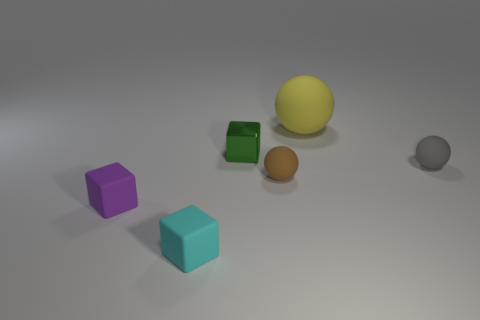Is there anything else that has the same material as the green thing?
Ensure brevity in your answer.  No. There is a rubber thing that is both in front of the tiny metal cube and right of the small brown rubber object; what is its size?
Provide a short and direct response. Small. There is a tiny thing that is behind the small gray thing; what shape is it?
Make the answer very short. Cube. Are the gray object and the small thing that is in front of the purple object made of the same material?
Provide a succinct answer. Yes. Do the tiny purple rubber object and the yellow object have the same shape?
Keep it short and to the point. No. There is a big yellow object that is the same shape as the brown rubber thing; what material is it?
Your response must be concise. Rubber. There is a tiny thing that is behind the tiny brown sphere and to the left of the large rubber ball; what is its color?
Your answer should be compact. Green. What is the color of the big matte thing?
Provide a short and direct response. Yellow. Are there any large blue rubber things of the same shape as the metallic thing?
Make the answer very short. No. What size is the ball that is behind the green block?
Provide a short and direct response. Large. 